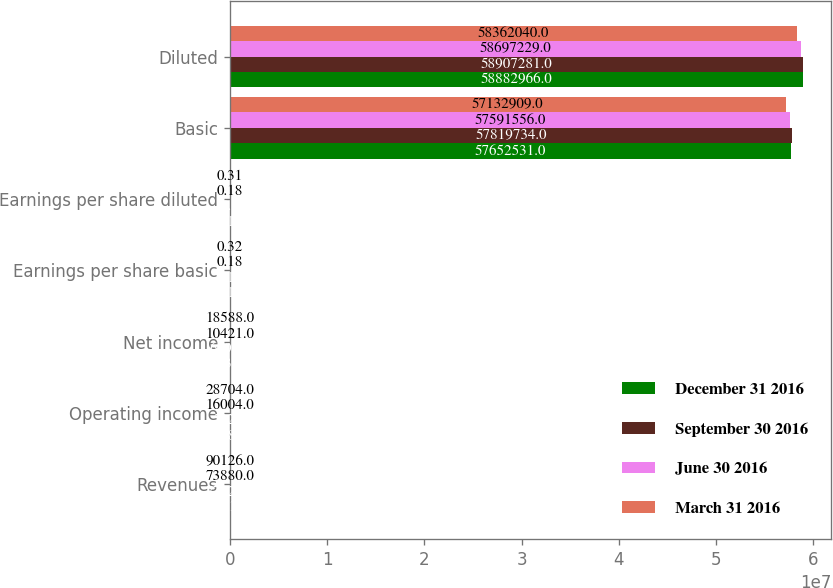Convert chart to OTSL. <chart><loc_0><loc_0><loc_500><loc_500><stacked_bar_chart><ecel><fcel>Revenues<fcel>Operating income<fcel>Net income<fcel>Earnings per share basic<fcel>Earnings per share diluted<fcel>Basic<fcel>Diluted<nl><fcel>December 31 2016<fcel>87810<fcel>12681<fcel>8633<fcel>0.15<fcel>0.15<fcel>5.76525e+07<fcel>5.8883e+07<nl><fcel>September 30 2016<fcel>77325<fcel>582<fcel>6198<fcel>0.11<fcel>0.1<fcel>5.78197e+07<fcel>5.89073e+07<nl><fcel>June 30 2016<fcel>73880<fcel>16004<fcel>10421<fcel>0.18<fcel>0.18<fcel>5.75916e+07<fcel>5.86972e+07<nl><fcel>March 31 2016<fcel>90126<fcel>28704<fcel>18588<fcel>0.32<fcel>0.31<fcel>5.71329e+07<fcel>5.8362e+07<nl></chart> 